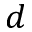<formula> <loc_0><loc_0><loc_500><loc_500>d</formula> 